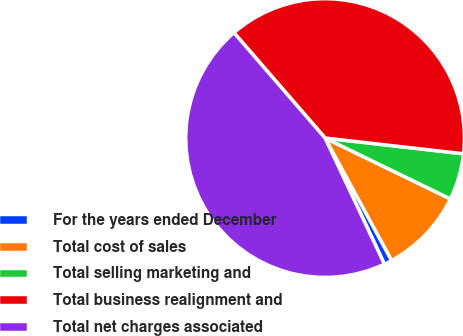<chart> <loc_0><loc_0><loc_500><loc_500><pie_chart><fcel>For the years ended December<fcel>Total cost of sales<fcel>Total selling marketing and<fcel>Total business realignment and<fcel>Total net charges associated<nl><fcel>0.93%<fcel>9.87%<fcel>5.4%<fcel>38.16%<fcel>45.65%<nl></chart> 